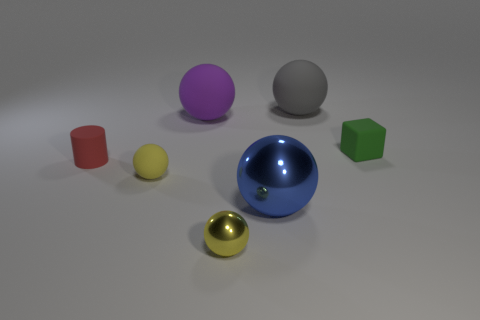How many yellow balls must be subtracted to get 1 yellow balls? 1 Add 3 green matte cubes. How many objects exist? 10 Subtract all large blue balls. How many balls are left? 4 Subtract all cylinders. How many objects are left? 6 Subtract 2 balls. How many balls are left? 3 Subtract all red balls. Subtract all red cylinders. How many balls are left? 5 Subtract all purple cubes. How many cyan cylinders are left? 0 Subtract all yellow rubber spheres. Subtract all small red spheres. How many objects are left? 6 Add 5 tiny blocks. How many tiny blocks are left? 6 Add 7 green blocks. How many green blocks exist? 8 